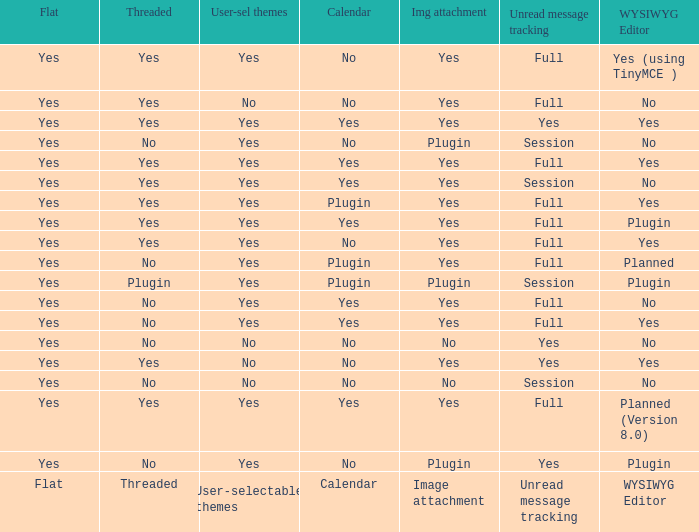Which Calendar has a User-selectable themes of user-selectable themes? Calendar. 